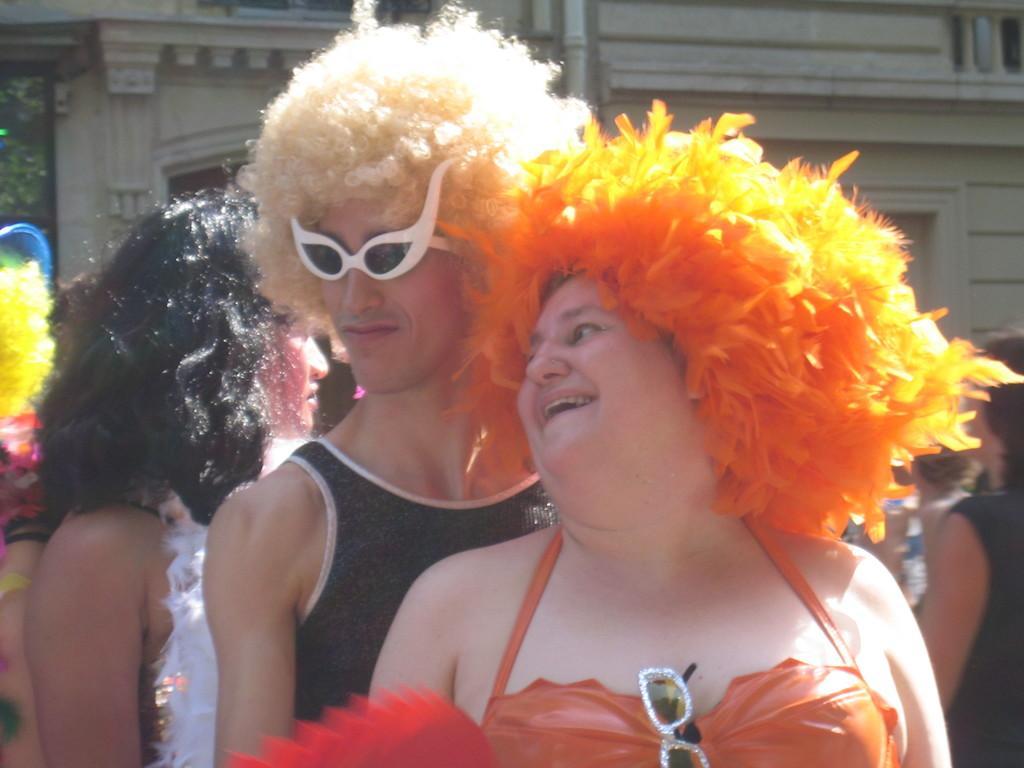Describe this image in one or two sentences. In this image there are a group of people who are standing and they are wearing some costumes, in the background there is a building. 